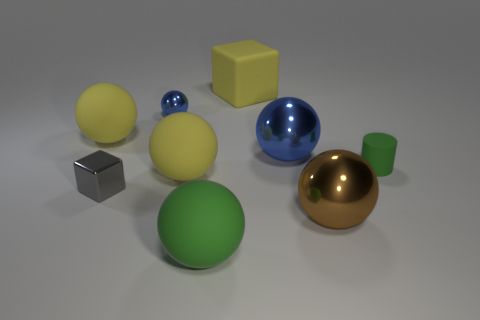Subtract all tiny spheres. How many spheres are left? 5 Subtract 5 spheres. How many spheres are left? 1 Subtract all spheres. How many objects are left? 3 Subtract all gray cubes. How many cubes are left? 1 Subtract all large green matte balls. Subtract all small blue objects. How many objects are left? 7 Add 5 large green matte objects. How many large green matte objects are left? 6 Add 8 big blocks. How many big blocks exist? 9 Subtract 0 purple cubes. How many objects are left? 9 Subtract all gray cylinders. Subtract all cyan cubes. How many cylinders are left? 1 Subtract all blue balls. How many red cubes are left? 0 